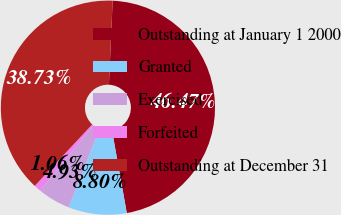Convert chart. <chart><loc_0><loc_0><loc_500><loc_500><pie_chart><fcel>Outstanding at January 1 2000<fcel>Granted<fcel>Exercised<fcel>Forfeited<fcel>Outstanding at December 31<nl><fcel>46.47%<fcel>8.8%<fcel>4.93%<fcel>1.06%<fcel>38.73%<nl></chart> 